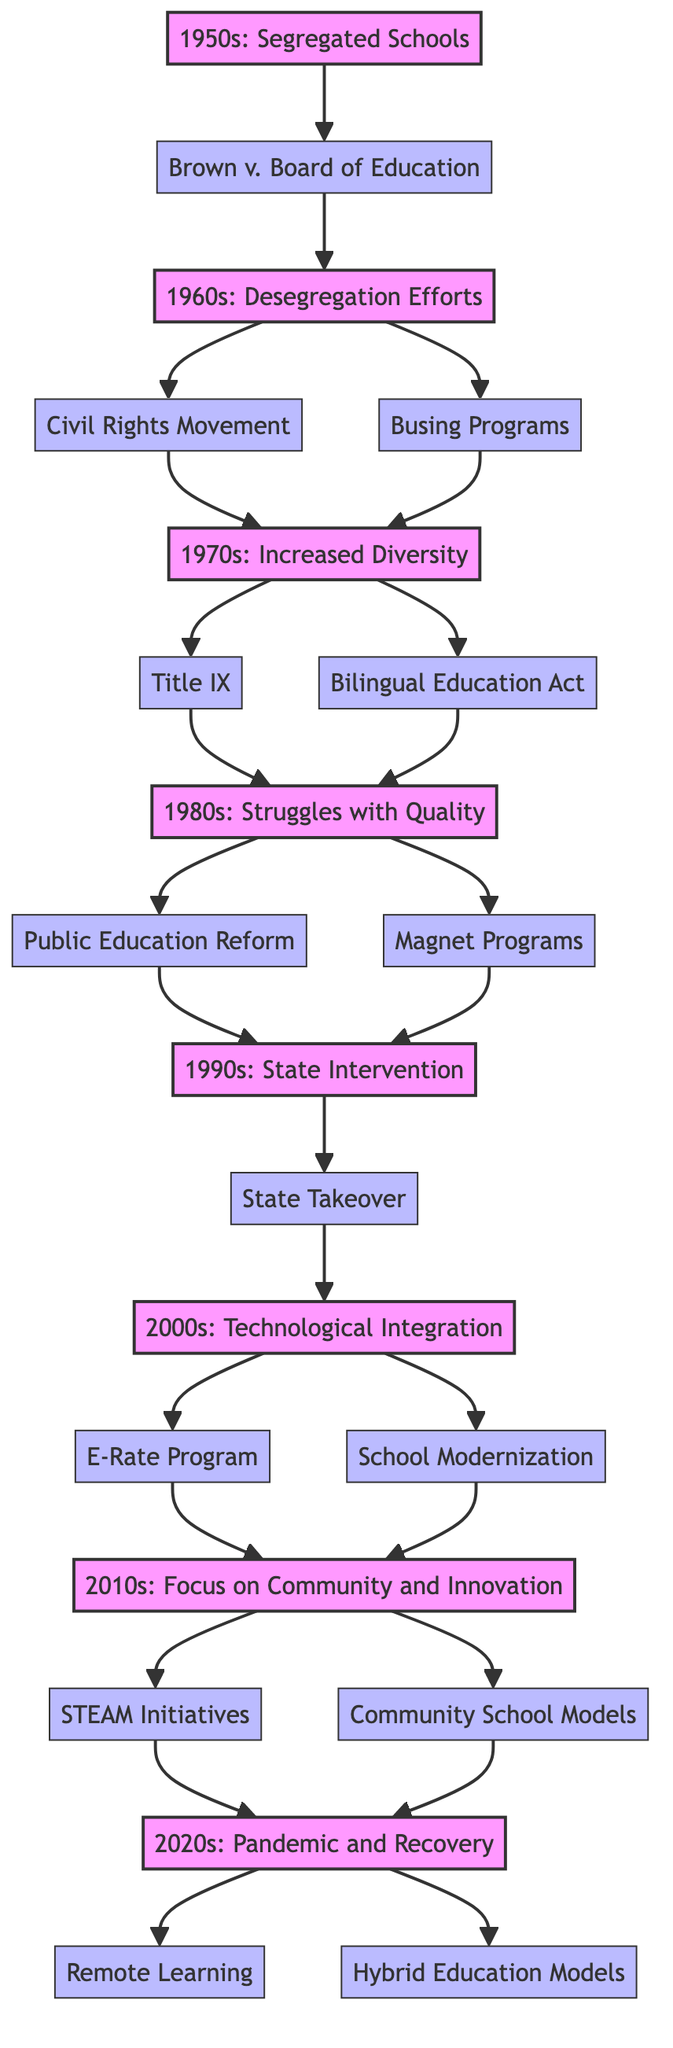What key initiative occurred in the 1950s? According to the diagram, the key initiative during the 1950s was the ruling of Brown v. Board of Education in 1954. This ruling initiated the desegregation of schools, thus being central to the educational changes in that decade.
Answer: Brown v. Board of Education How many decades are represented in the diagram? By counting the distinct periods listed, the diagram represents a total of eight decades: from the 1950s to the 2020s. Each decade is represented by its respective node in the flow chart.
Answer: 8 Which decade did the State Takeover occur? The diagram indicates that the State Takeover occurred in the 1990s, as it is directly linked from the struggles depicted during that decade.
Answer: 1990s What is the relationship between the 1980s and the 1990s? The relationship shows that issues from the 1980s, such as underfunding and overcrowding, ultimately led to State Intervention starting in the 1990s. The arrows between these decades signal a direct progression from one to the next.
Answer: State Intervention In which decade was the E-Rate Program introduced? The E-Rate Program was introduced in the 2000s, as indicated by the direct link coming from that decade in the diagram.
Answer: 2000s Which initiatives are connected to the 2010s? The initiatives directly connected to the 2010s include STEAM Initiatives and Community School Models, as illustrated by the branches extending from the decade node.
Answer: STEAM Initiatives, Community School Models What does the transition from the 1960s to the 1970s signify? The transition from the 1960s to the 1970s signifies a progression from the desegregation efforts initiated by the Civil Rights Movement and Busing Programs in the 1960s to a more diverse school demographic in the 1970s, as represented in the flow chart.
Answer: Increased Diversity Which decade faced struggles related to infrastructure? The 1980s faced significant struggles related to infrastructure, as it mentions issues like overcrowding and deteriorating school conditions, detailing the challenges that education faced during this time.
Answer: 1980s 